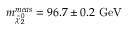Convert formula to latex. <formula><loc_0><loc_0><loc_500><loc_500>m _ { \tilde { \chi } _ { 2 } ^ { 0 } } ^ { m e a s } = 9 6 . 7 \pm 0 . 2 \ G e V</formula> 